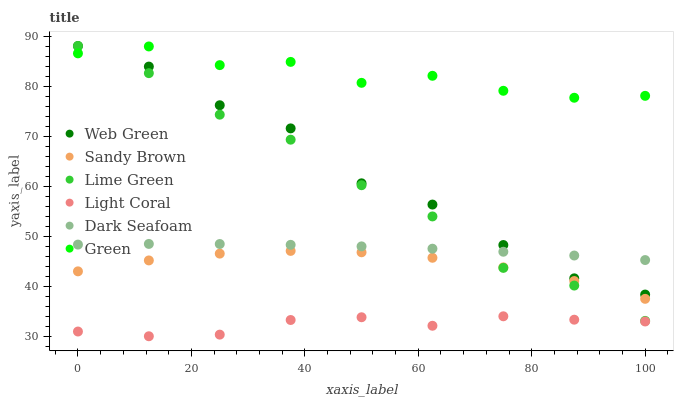Does Light Coral have the minimum area under the curve?
Answer yes or no. Yes. Does Green have the maximum area under the curve?
Answer yes or no. Yes. Does Web Green have the minimum area under the curve?
Answer yes or no. No. Does Web Green have the maximum area under the curve?
Answer yes or no. No. Is Dark Seafoam the smoothest?
Answer yes or no. Yes. Is Web Green the roughest?
Answer yes or no. Yes. Is Light Coral the smoothest?
Answer yes or no. No. Is Light Coral the roughest?
Answer yes or no. No. Does Light Coral have the lowest value?
Answer yes or no. Yes. Does Web Green have the lowest value?
Answer yes or no. No. Does Lime Green have the highest value?
Answer yes or no. Yes. Does Light Coral have the highest value?
Answer yes or no. No. Is Sandy Brown less than Dark Seafoam?
Answer yes or no. Yes. Is Dark Seafoam greater than Light Coral?
Answer yes or no. Yes. Does Web Green intersect Dark Seafoam?
Answer yes or no. Yes. Is Web Green less than Dark Seafoam?
Answer yes or no. No. Is Web Green greater than Dark Seafoam?
Answer yes or no. No. Does Sandy Brown intersect Dark Seafoam?
Answer yes or no. No. 